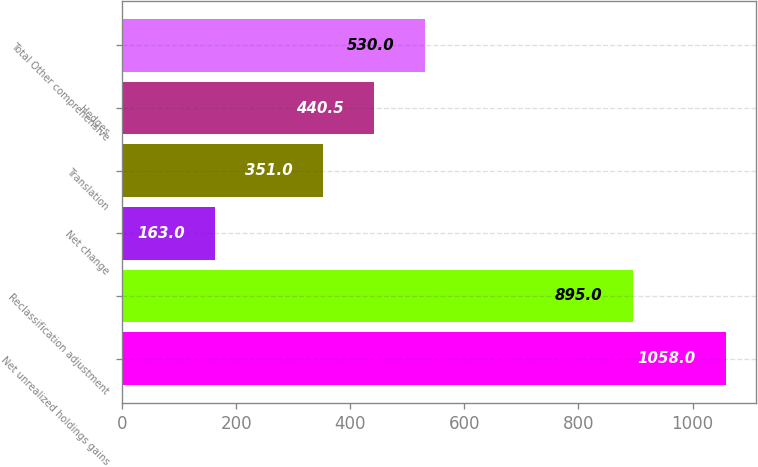<chart> <loc_0><loc_0><loc_500><loc_500><bar_chart><fcel>Net unrealized holdings gains<fcel>Reclassification adjustment<fcel>Net change<fcel>Translation<fcel>Hedges<fcel>Total Other comprehensive<nl><fcel>1058<fcel>895<fcel>163<fcel>351<fcel>440.5<fcel>530<nl></chart> 